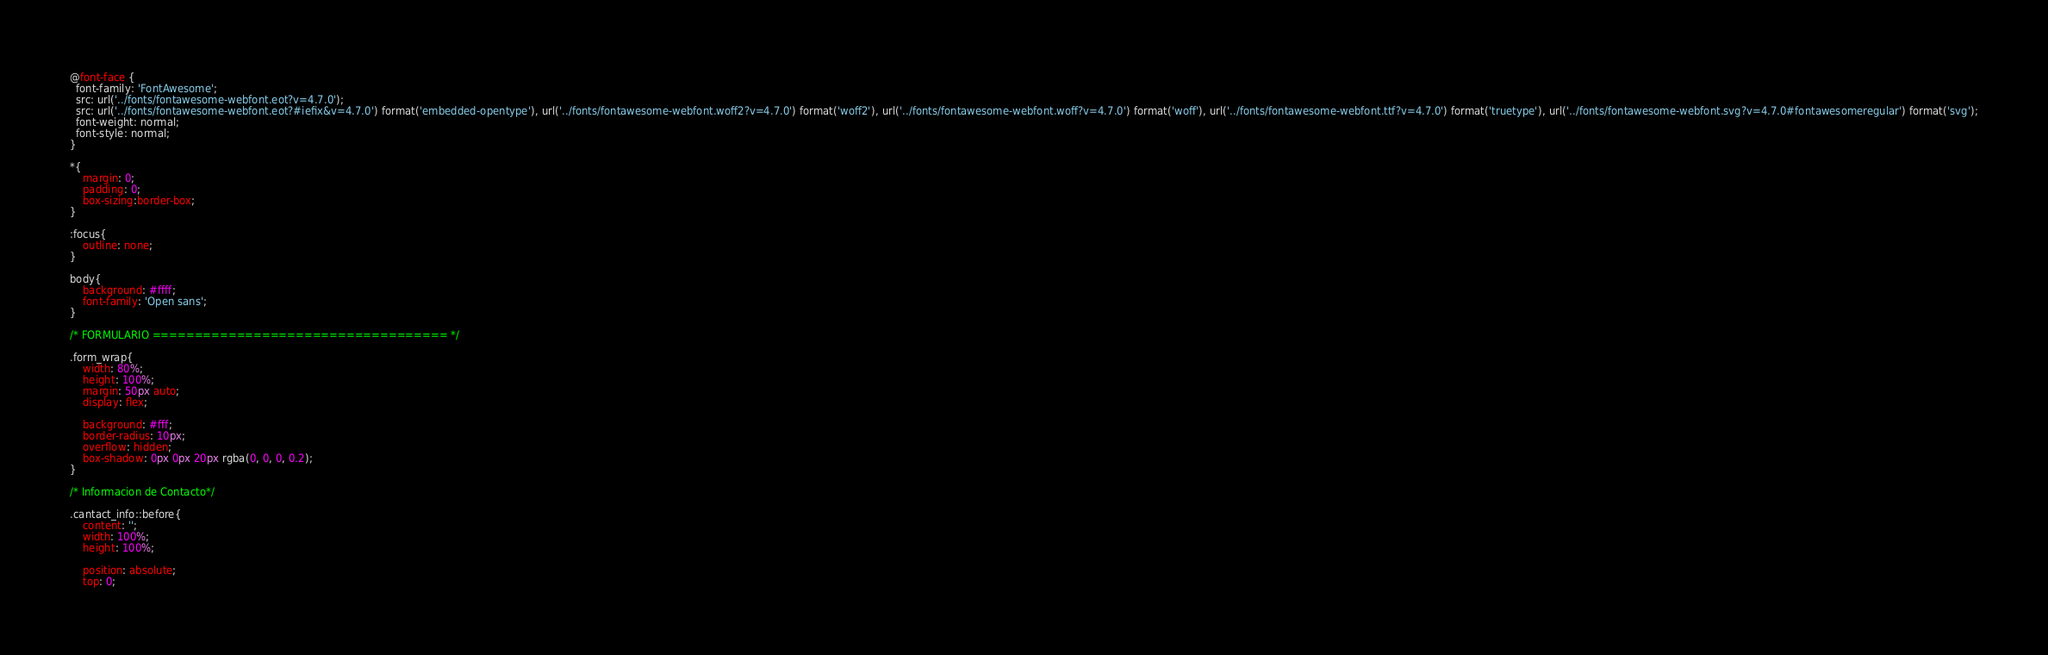<code> <loc_0><loc_0><loc_500><loc_500><_CSS_>@font-face {
  font-family: 'FontAwesome';
  src: url('../fonts/fontawesome-webfont.eot?v=4.7.0');
  src: url('../fonts/fontawesome-webfont.eot?#iefix&v=4.7.0') format('embedded-opentype'), url('../fonts/fontawesome-webfont.woff2?v=4.7.0') format('woff2'), url('../fonts/fontawesome-webfont.woff?v=4.7.0') format('woff'), url('../fonts/fontawesome-webfont.ttf?v=4.7.0') format('truetype'), url('../fonts/fontawesome-webfont.svg?v=4.7.0#fontawesomeregular') format('svg');
  font-weight: normal;
  font-style: normal;
}

*{
    margin: 0;
    padding: 0;
    box-sizing:border-box;
}

:focus{
    outline: none;
}

body{
    background: #ffff;
    font-family: 'Open sans';
}

/* FORMULARIO =================================== */

.form_wrap{
    width: 80%;
    height: 100%;
    margin: 50px auto;
    display: flex;

    background: #fff;
    border-radius: 10px;
    overflow: hidden;
    box-shadow: 0px 0px 20px rgba(0, 0, 0, 0.2);
}

/* Informacion de Contacto*/

.cantact_info::before{
    content: '';
    width: 100%;
    height: 100%;

    position: absolute;
    top: 0;</code> 